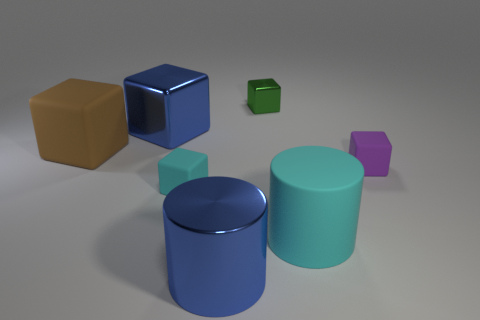What is the material of the thing that is the same color as the matte cylinder?
Provide a short and direct response. Rubber. What is the color of the big cylinder that is left of the tiny green object?
Make the answer very short. Blue. How many objects are either small cyan blocks on the left side of the green shiny object or matte objects that are to the right of the brown thing?
Provide a succinct answer. 3. Does the brown block have the same size as the green metallic block?
Keep it short and to the point. No. How many spheres are large metal things or large brown rubber objects?
Your response must be concise. 0. How many objects are to the right of the brown rubber cube and behind the blue cylinder?
Offer a very short reply. 5. There is a matte cylinder; is its size the same as the green thing that is behind the brown rubber block?
Keep it short and to the point. No. Are there any small green blocks that are in front of the metal cube on the right side of the tiny rubber block that is left of the green metal thing?
Provide a succinct answer. No. What is the cyan object that is in front of the tiny cyan rubber object that is on the left side of the small purple rubber block made of?
Your response must be concise. Rubber. What material is the block that is in front of the large metal block and behind the purple matte block?
Provide a short and direct response. Rubber. 